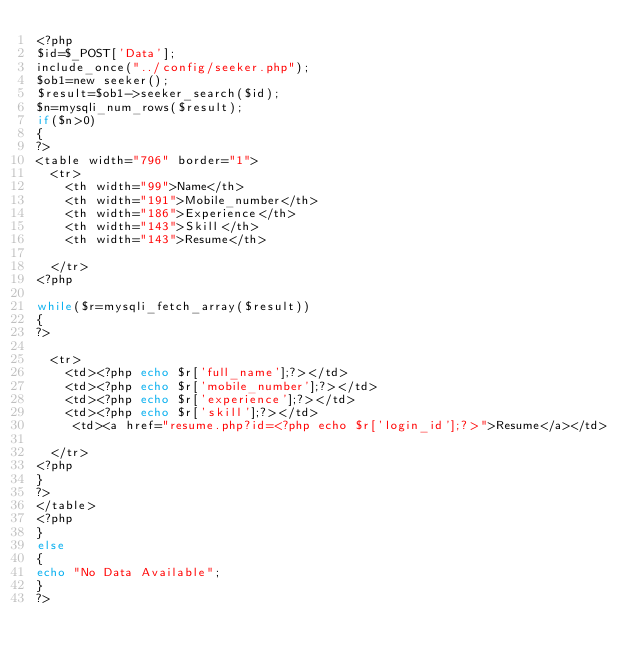Convert code to text. <code><loc_0><loc_0><loc_500><loc_500><_PHP_><?php
$id=$_POST['Data'];
include_once("../config/seeker.php");
$ob1=new seeker();
$result=$ob1->seeker_search($id);
$n=mysqli_num_rows($result);
if($n>0)
{
?>
<table width="796" border="1">
  <tr>
    <th width="99">Name</th>
    <th width="191">Mobile_number</th>
    <th width="186">Experience</th>
    <th width="143">Skill</th>
    <th width="143">Resume</th>
    
  </tr>
<?php

while($r=mysqli_fetch_array($result))
{
?>

  <tr>
    <td><?php echo $r['full_name'];?></td>
    <td><?php echo $r['mobile_number'];?></td>
    <td><?php echo $r['experience'];?></td>
    <td><?php echo $r['skill'];?></td>
     <td><a href="resume.php?id=<?php echo $r['login_id'];?>">Resume</a></td>

  </tr>
<?php
}
?>
</table>
<?php
}
else
{
echo "No Data Available";
}
?>

</code> 